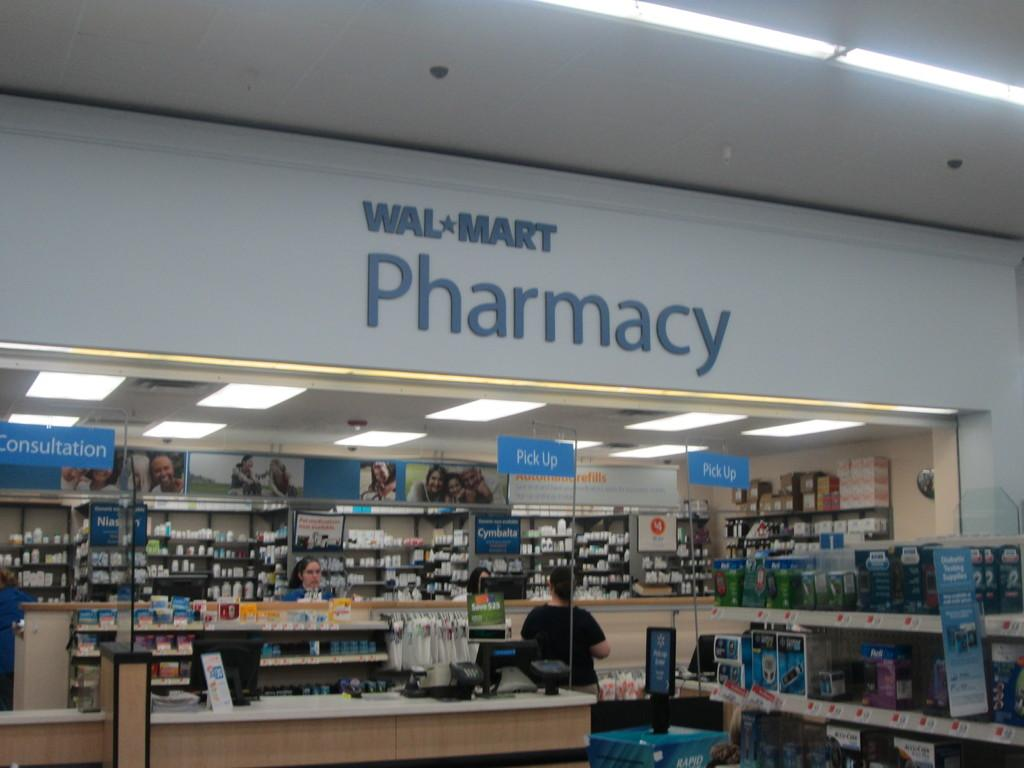<image>
Relay a brief, clear account of the picture shown. A woman standing at the Wal Mart Pharmacy counter. 